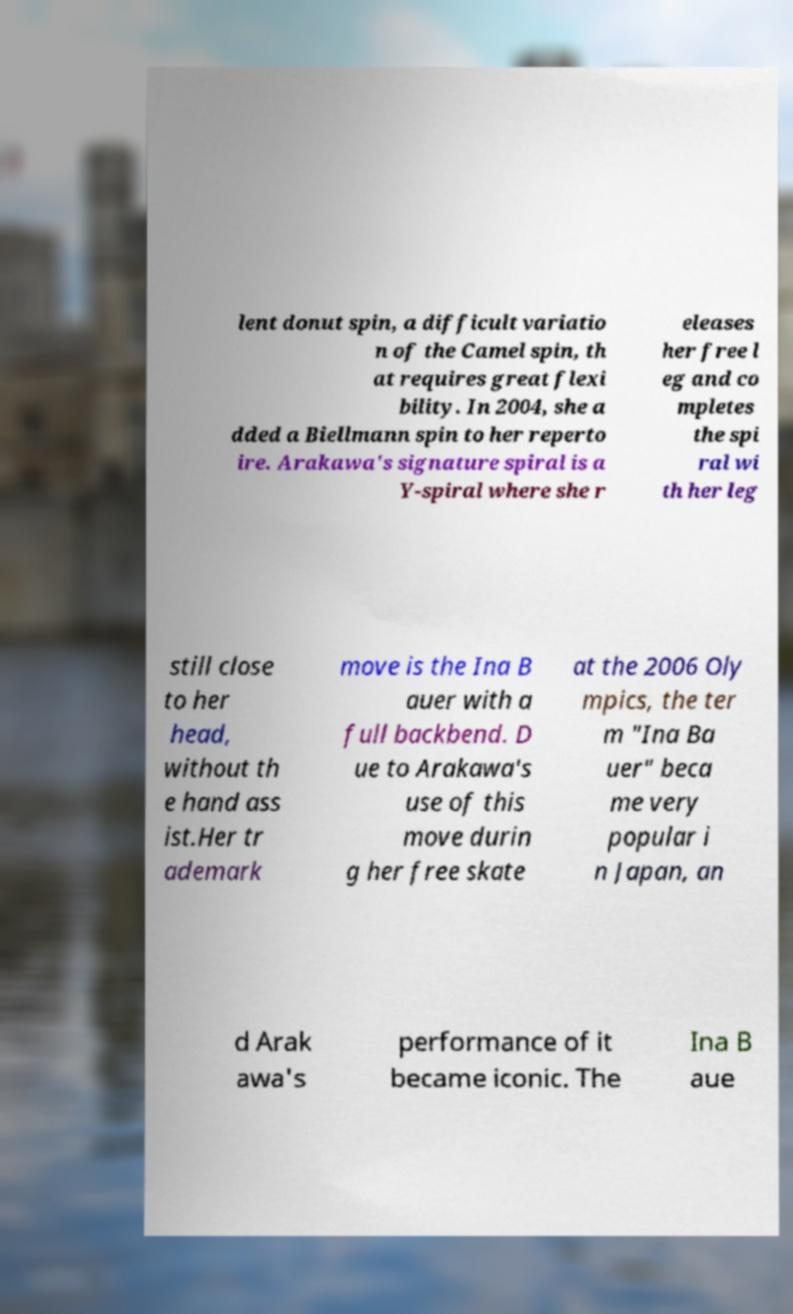Please identify and transcribe the text found in this image. lent donut spin, a difficult variatio n of the Camel spin, th at requires great flexi bility. In 2004, she a dded a Biellmann spin to her reperto ire. Arakawa's signature spiral is a Y-spiral where she r eleases her free l eg and co mpletes the spi ral wi th her leg still close to her head, without th e hand ass ist.Her tr ademark move is the Ina B auer with a full backbend. D ue to Arakawa's use of this move durin g her free skate at the 2006 Oly mpics, the ter m "Ina Ba uer" beca me very popular i n Japan, an d Arak awa's performance of it became iconic. The Ina B aue 